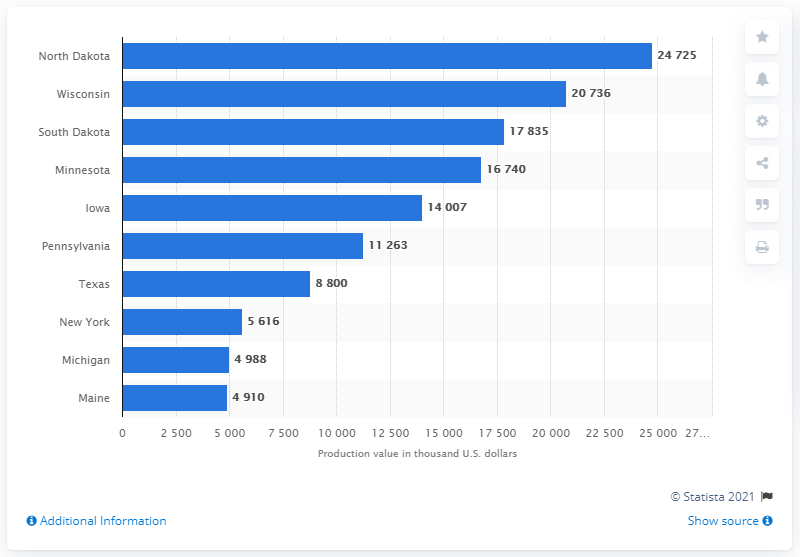Indicate a few pertinent items in this graphic. In 2019, Michigan produced 5.6 million dollars worth of oats. 